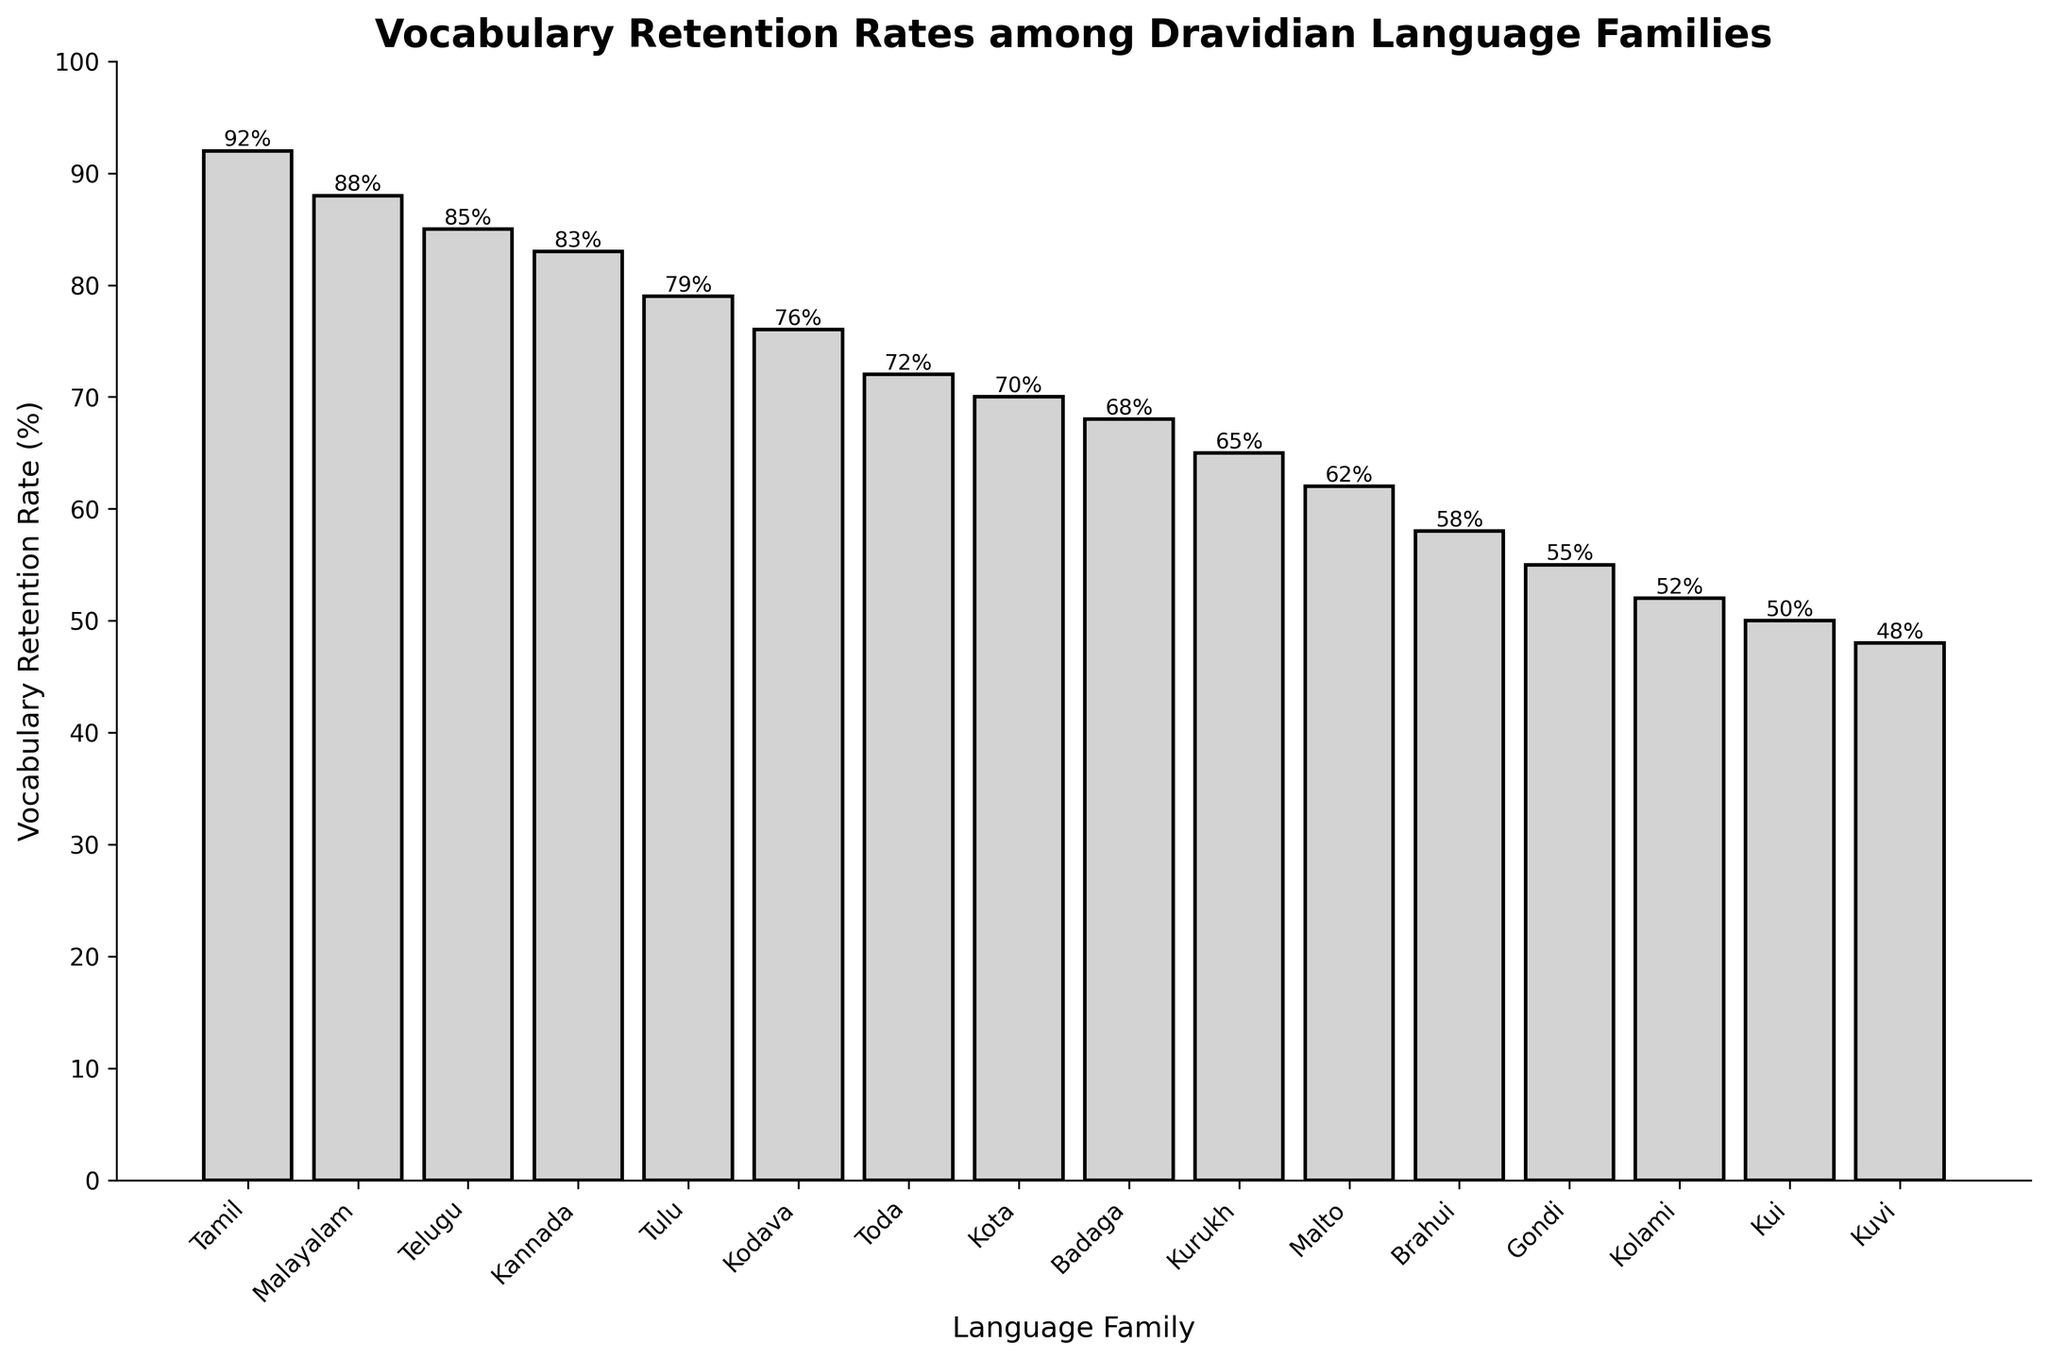Which language family has the highest Vocabulary Retention Rate? The tallest bar in the figure represents the language family with the highest retention rate. The highest bar corresponds to the Tamil language family.
Answer: Tamil Which language family has a Vocabulary Retention Rate of 55%? We locate the bar corresponding to a height of 55%. The label below this bar indicates the language family. The language family with a 55% retention rate is Gondi.
Answer: Gondi What is the difference in Vocabulary Retention Rate between Tamil and Kannada? The bar for Tamil is at 92%, and the bar for Kannada is at 83%. The difference is calculated by subtracting the lower value from the higher value: 92% - 83% = 9%.
Answer: 9% Which language families have Vocabulary Retention Rates higher than 80%? We look for bars that exceed the 80% mark on the y-axis. These correspond to the language families: Tamil, Malayalam, Telugu, and Kannada.
Answer: Tamil, Malayalam, Telugu, Kannada What is the average Vocabulary Retention Rate of the Toda, Kota, and Badaga language families? The individual retention rates are: Toda (72%), Kota (70%), and Badaga (68%). Calculate the average by summing these rates and dividing by the number of families: (72% + 70% + 68%) / 3 = 70%.
Answer: 70% Which language family has a Vocabulary Retention Rate closest to 65%? Examining the bars near 65% on the y-axis, the Kurukh language family's bar is at 65%.
Answer: Kurukh How much lower is the Vocabulary Retention Rate of Brahui compared to Malayalam? Brahui's retention rate is 58%, and Malayalam's is 88%. The difference is calculated by subtracting the lower value from the higher value: 88% - 58% = 30%.
Answer: 30% What is the median Vocabulary Retention Rate of all listed Dravidian language families? Ordering the retention rates, the median is the middle value, which in this case (for 17 values) is the 9th value when arranged in ascending order. Ordered rates: 48%, 50%, 52%, 55%, 58%, 62%, 65%, 68%, **70%**, 72%, 76%, 79%, 83%, 85%, 88%, 92%. The 9th value is 70%.
Answer: 70% Between Kui and Kuvi, which language family has a lower Vocabulary Retention Rate and by how much? Kui has a retention rate of 50% and Kuvi 48%. Kui's rate is 50% - 48% = 2% higher than Kuvi's. So, Kuvi has the lower rate by 2%.
Answer: Kuvi, 2% 